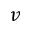<formula> <loc_0><loc_0><loc_500><loc_500>v</formula> 